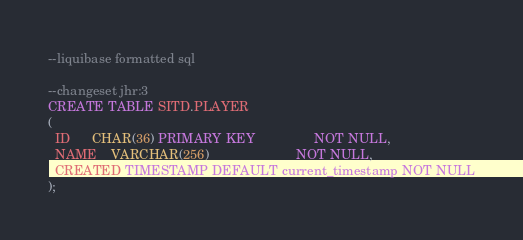<code> <loc_0><loc_0><loc_500><loc_500><_SQL_>--liquibase formatted sql

--changeset jhr:3
CREATE TABLE SITD.PLAYER
(
  ID      CHAR(36) PRIMARY KEY                NOT NULL,
  NAME    VARCHAR(256)                        NOT NULL,
  CREATED TIMESTAMP DEFAULT current_timestamp NOT NULL
);</code> 